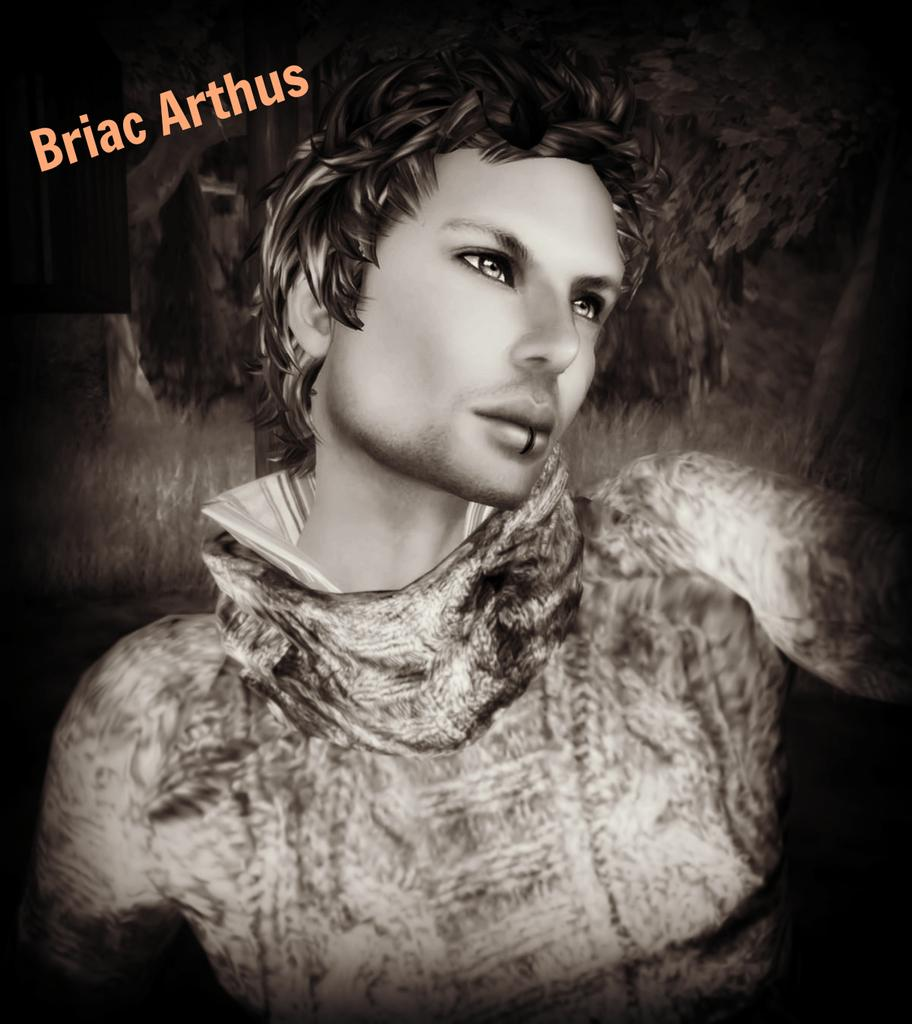What type of image is being described? The image is a graphical image. What is depicted in the image? There is a cartoon of a person in the image. Where is the text located in the image? The text is on the left side of the image. What is the color of the background in the image? The background of the image is dark. What type of soap is being used by the women in the image? There are no women or soap present in the image; it features a cartoon of a person and some text on a dark background. 